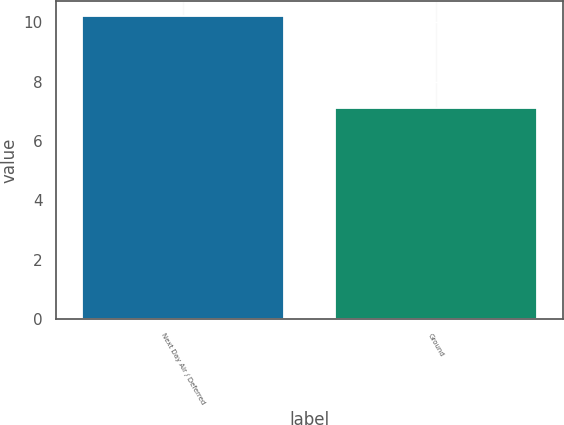Convert chart. <chart><loc_0><loc_0><loc_500><loc_500><bar_chart><fcel>Next Day Air / Deferred<fcel>Ground<nl><fcel>10.2<fcel>7.1<nl></chart> 